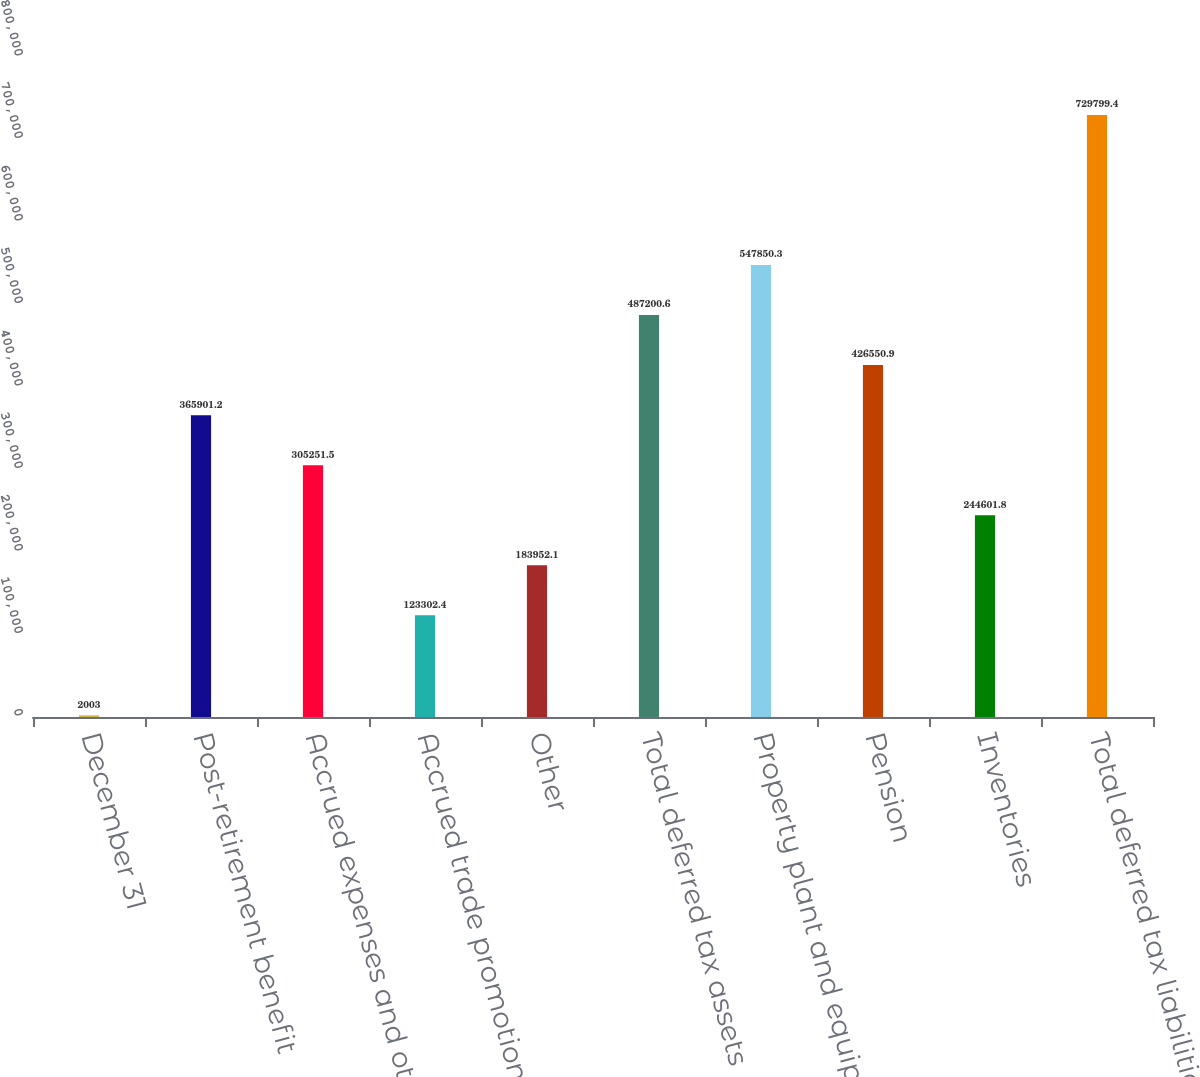Convert chart to OTSL. <chart><loc_0><loc_0><loc_500><loc_500><bar_chart><fcel>December 31<fcel>Post-retirement benefit<fcel>Accrued expenses and other<fcel>Accrued trade promotion<fcel>Other<fcel>Total deferred tax assets<fcel>Property plant and equipment<fcel>Pension<fcel>Inventories<fcel>Total deferred tax liabilities<nl><fcel>2003<fcel>365901<fcel>305252<fcel>123302<fcel>183952<fcel>487201<fcel>547850<fcel>426551<fcel>244602<fcel>729799<nl></chart> 